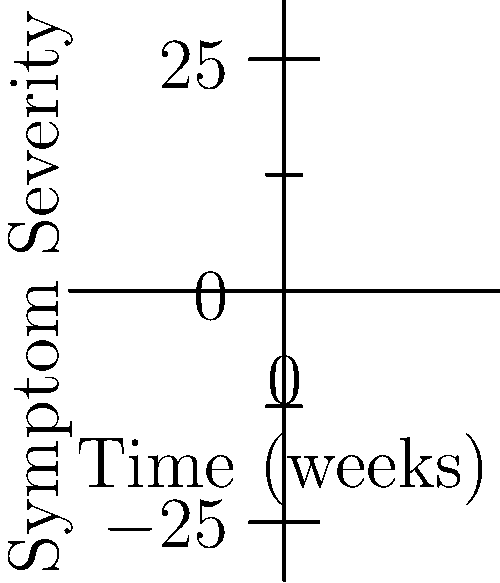As a naturopathic doctor, you're comparing two treatment plans for a patient with chronic fatigue syndrome. The graph shows the predicted symptom severity over time for two different treatments, A and B, represented by polynomial functions. Treatment A is described by $f(x) = -0.5x^3 + 6x^2 - 18x + 20$, and Treatment B by $g(x) = 0.25x^3 - 2x^2 + 5x + 10$, where $x$ represents time in weeks. At which week do the two treatments yield the same symptom severity, and which treatment would you recommend for long-term management beyond this point? To solve this problem, we need to follow these steps:

1) Find the intersection point of the two functions by equating them:
   $f(x) = g(x)$
   $-0.5x^3 + 6x^2 - 18x + 20 = 0.25x^3 - 2x^2 + 5x + 10$

2) Simplify the equation:
   $-0.75x^3 + 8x^2 - 23x + 10 = 0$

3) This cubic equation can be solved using a graphing calculator or computer algebra system. The solution is approximately $x = 4$ weeks.

4) To determine which treatment is better for long-term management, we need to compare the functions after the intersection point:

   For $x > 4$:
   - Treatment A (blue curve) shows a decreasing trend in symptom severity.
   - Treatment B (red curve) shows an increasing trend in symptom severity.

5) Therefore, Treatment A would be recommended for long-term management as it leads to a continued decrease in symptom severity beyond the 4-week mark.

As a naturopathic doctor, it's important to note that while Treatment B shows faster initial improvement, Treatment A provides better long-term results, which is often preferable for chronic conditions like chronic fatigue syndrome.
Answer: The treatments yield the same symptom severity at week 4. Recommend Treatment A for long-term management. 